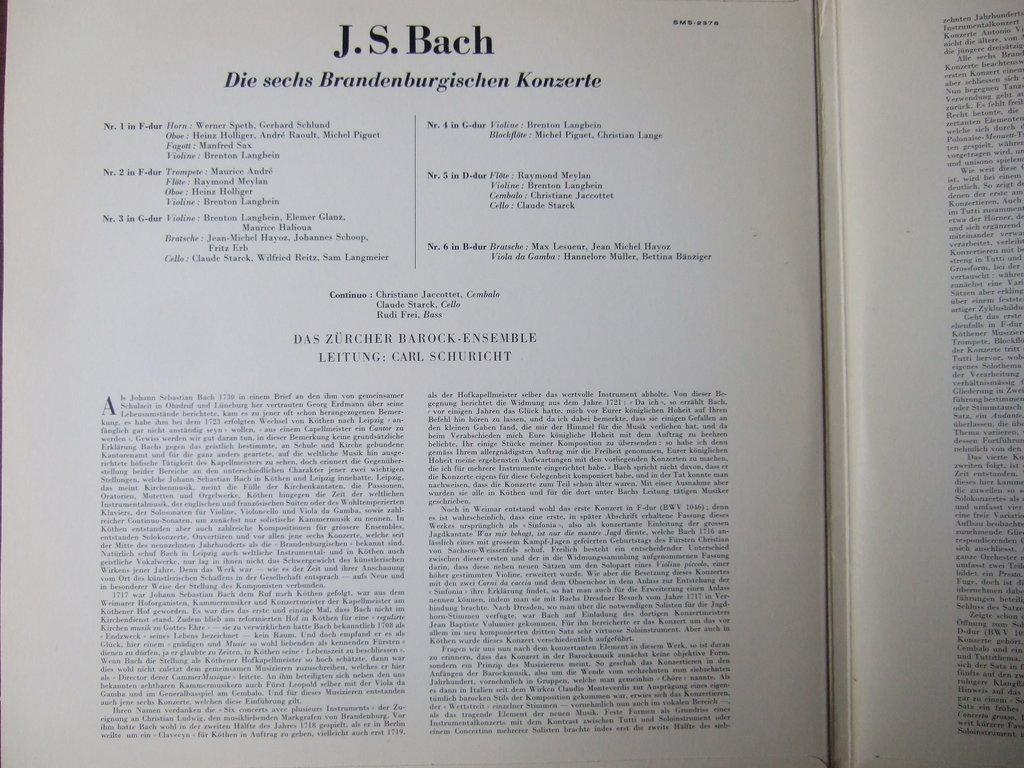What is visible on the pages of the book in the image? There are pages of a book visible in the image. What can be seen on the pages of the book? There is writing on the pages of the book. What type of mass is being conducted in the image? There is no mass present in the image; it features pages of a book with writing on them. What color is the rose on the table in the image? There is no rose present in the image. 